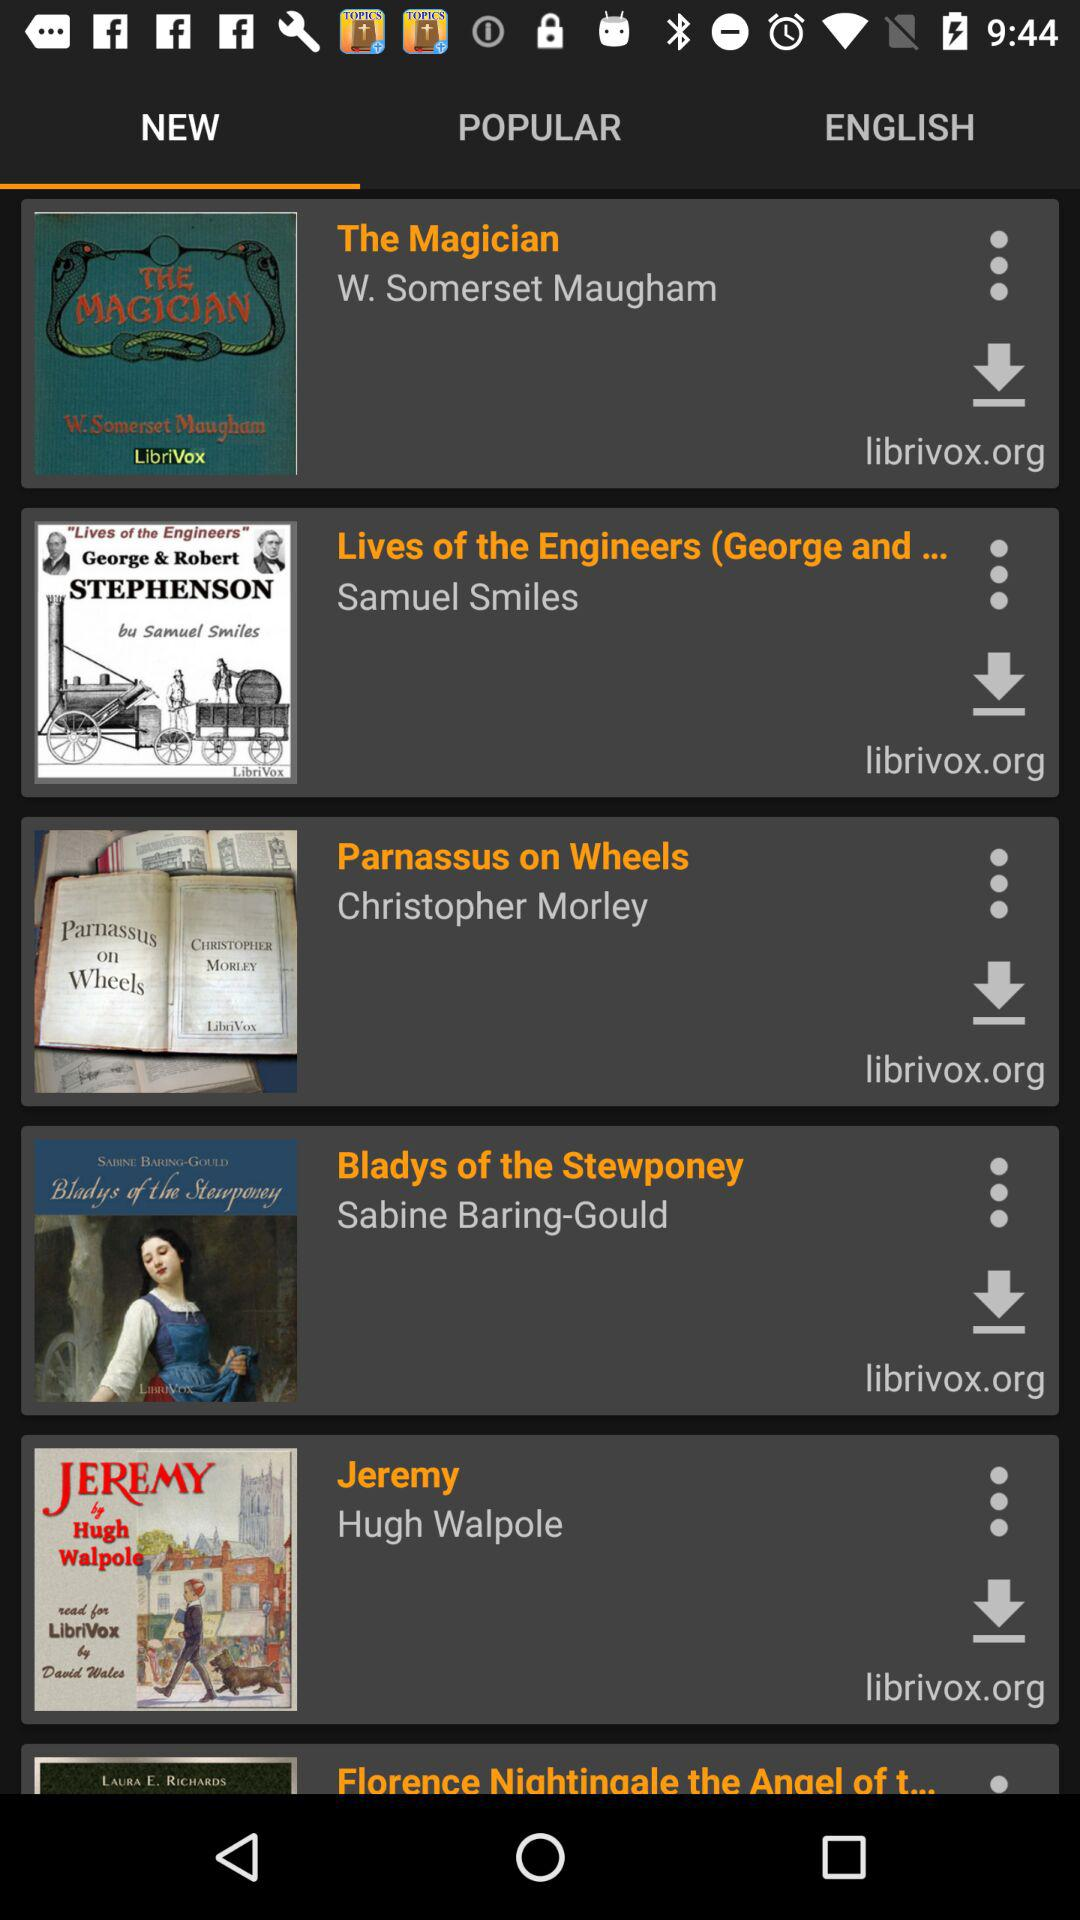Who has written the book "Parnassus on Wheels"? The book is written by Christopher Morley. 